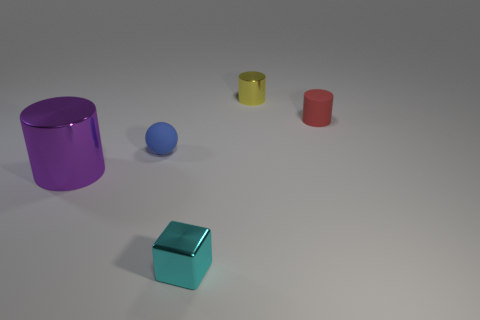Add 1 small blue balls. How many objects exist? 6 Subtract all spheres. How many objects are left? 4 Subtract 0 red balls. How many objects are left? 5 Subtract all red cylinders. Subtract all large purple metallic cylinders. How many objects are left? 3 Add 5 small cyan metal cubes. How many small cyan metal cubes are left? 6 Add 5 tiny rubber balls. How many tiny rubber balls exist? 6 